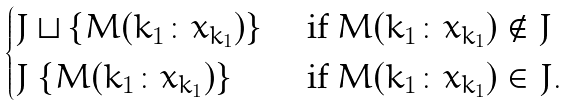<formula> <loc_0><loc_0><loc_500><loc_500>\begin{cases} J \sqcup \{ M ( k _ { 1 } \colon { x } _ { k _ { 1 } } ) \} & \text { if } M ( k _ { 1 } \colon { x } _ { k _ { 1 } } ) \not \in J \\ J \ \{ M ( k _ { 1 } \colon { x } _ { k _ { 1 } } ) \} & \text { if } M ( k _ { 1 } \colon { x } _ { k _ { 1 } } ) \in J . \end{cases}</formula> 